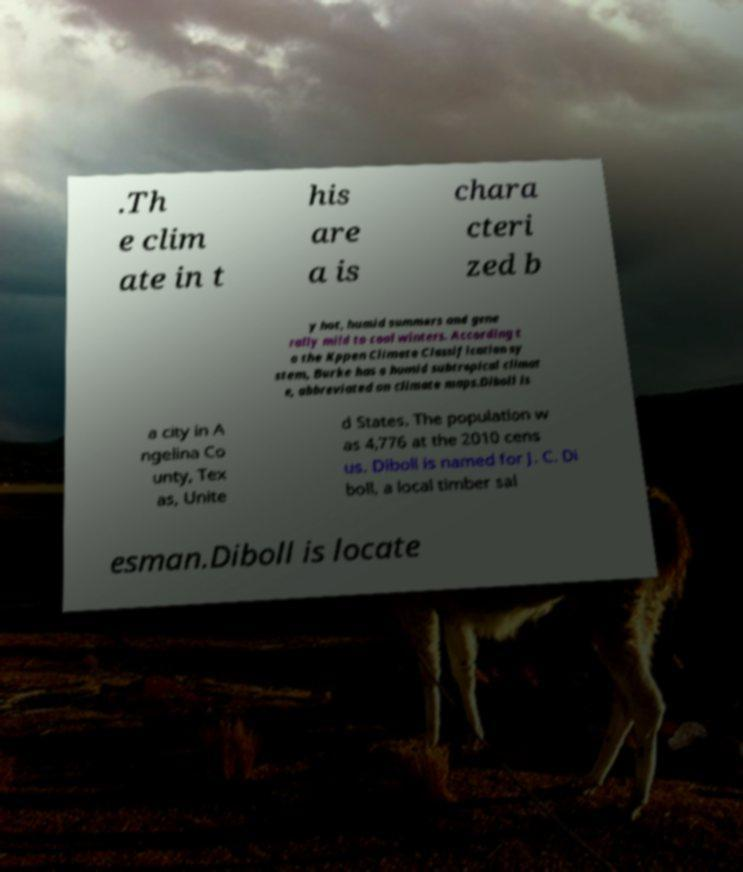Could you extract and type out the text from this image? .Th e clim ate in t his are a is chara cteri zed b y hot, humid summers and gene rally mild to cool winters. According t o the Kppen Climate Classification sy stem, Burke has a humid subtropical climat e, abbreviated on climate maps.Diboll is a city in A ngelina Co unty, Tex as, Unite d States. The population w as 4,776 at the 2010 cens us. Diboll is named for J. C. Di boll, a local timber sal esman.Diboll is locate 